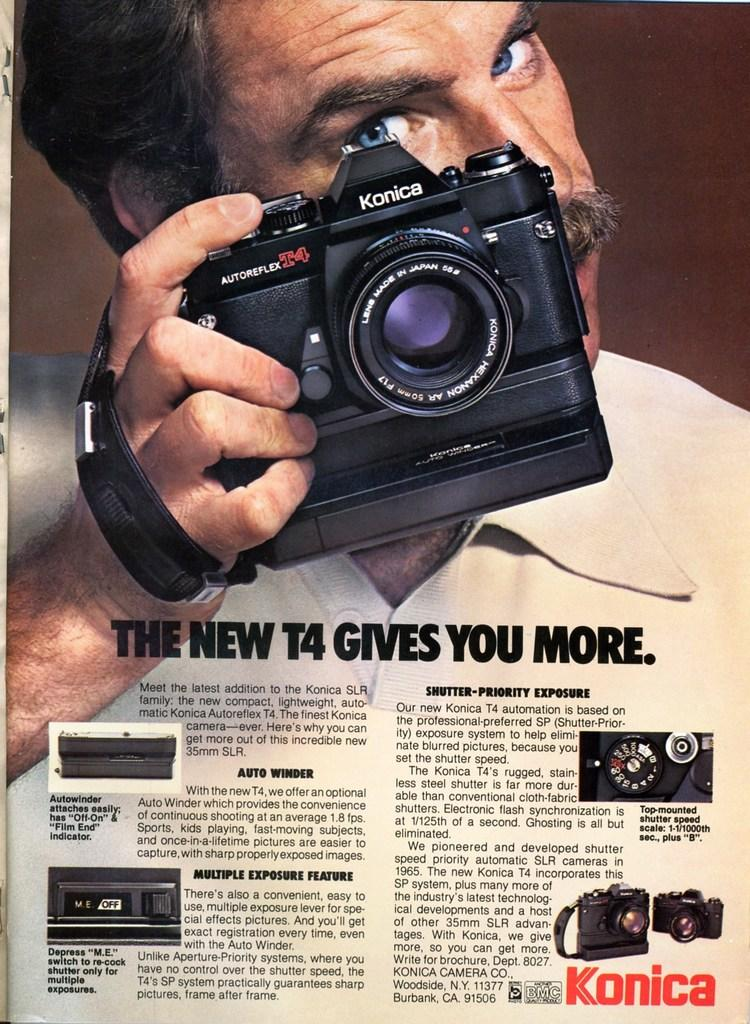Who is the main subject in the image? There is a man in the image. What is the man holding in the image? The man is holding a camera. What can be found at the bottom of the image? There is text at the bottom of the image. What type of visual might this be? The image appears to be a poster. How many brothers does the man in the image have? There is no information about the man's brothers in the image. 